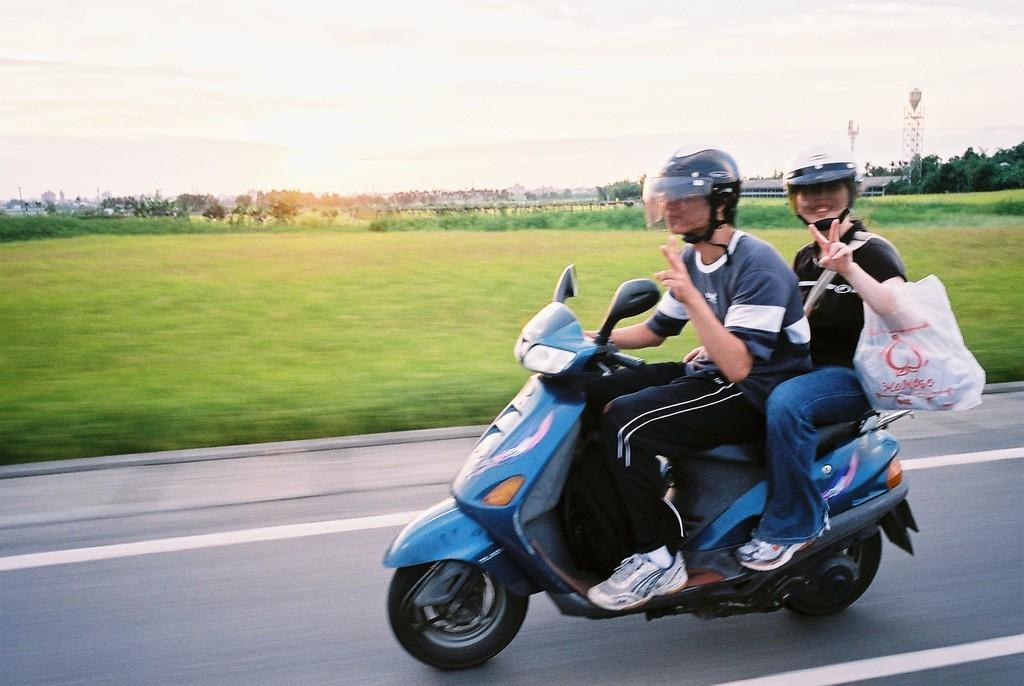In one or two sentences, can you explain what this image depicts? Two persons are sitting on scooter and riding. Both of them are wearing helmets. Back person is having a cover. In the background there is green grass and trees and sky. Also there are some buildings. 